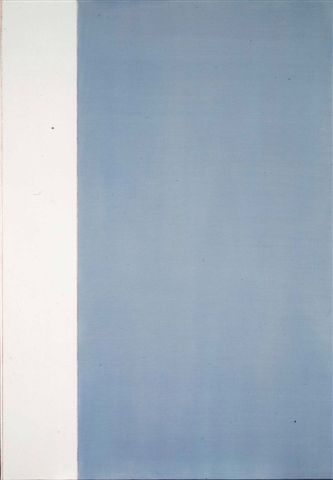Let’s talk about this artwork in the context of a science fiction story. In a distant future, humanity has colonized an alien planet. This artwork is displayed in the main hall of the colony's headquarters, representing the balance between the untouched, pure nature of the new world (white section) and the technologically advanced yet harmonious life humans have built (blue section). The gradient signifies the progress and adaptation of humanity to the new environment, moving from simplicity to complexity without losing its essence. It serves as a reminder of their symbiotic existence with the alien planet, a testament to their journey and the balanced utopia they strive to maintain. What extraordinary element could be hidden within this gradient blue section? Hidden within the gradient blue section is an ancient alien artifact, visible only under a certain spectrum of light. This artifact holds immense power, capable of altering time and space. When the light hits it at just the right angle, it reveals inscriptions that tell the history of a long-lost civilization that mastered interstellar travel and knowledge far beyond human comprehension. The artwork thus becomes a portal, a clue to uncovering secrets that could revolutionize humanity's understanding of the universe and its place within it. 